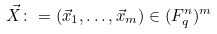Convert formula to latex. <formula><loc_0><loc_0><loc_500><loc_500>\vec { X } \colon = ( \vec { x } _ { 1 } , \dots , \vec { x } _ { m } ) \in ( F _ { q } ^ { n } ) ^ { m }</formula> 